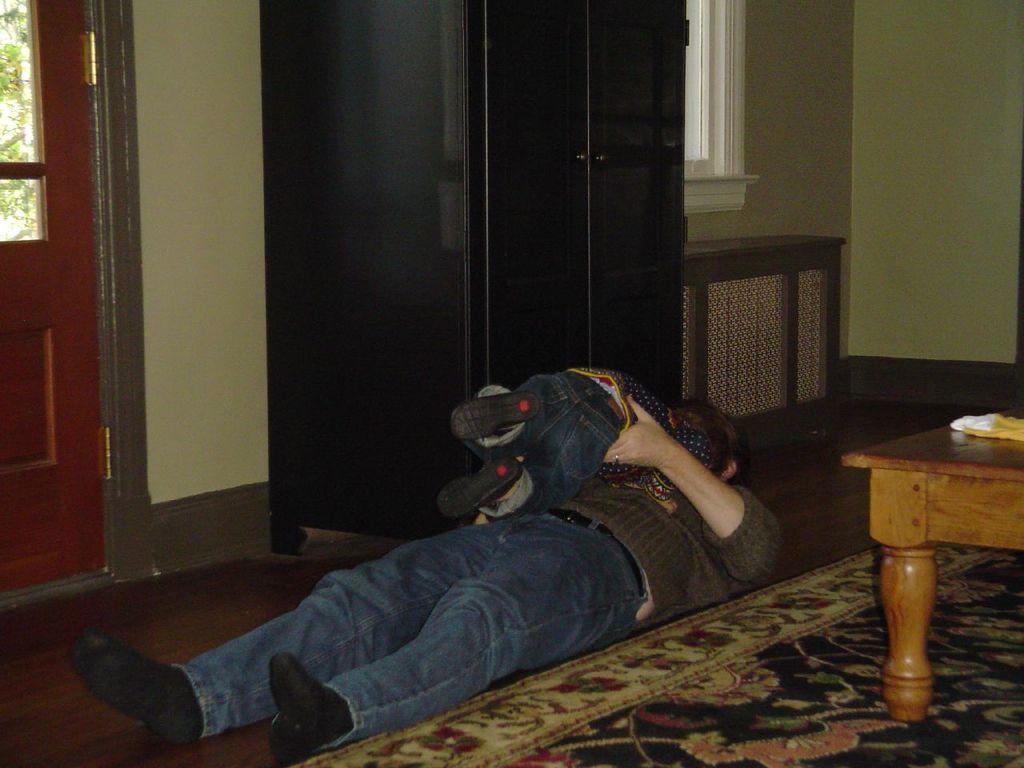Can you describe this image briefly? This is the picture of a man and baby sleeping in the floor near the carpet and in background we have cupboard , door, window, table. 